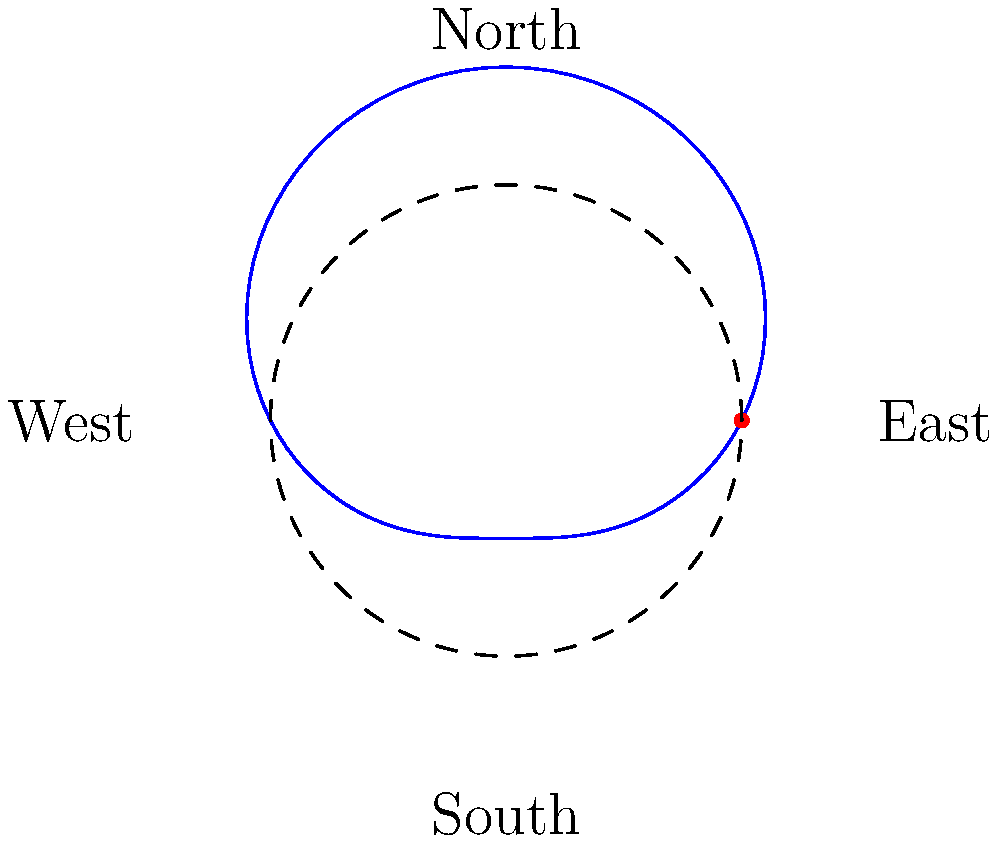In Padmabila Union, the daily movement of the sun across the sky can be represented using polar coordinates. If we consider the origin as the observer's position, east as the polar axis, and the angular coordinate measured counterclockwise from east, which equation best describes the sun's path?

A) $r = 4 + 2\sin(\theta)$
B) $r = 4 + 2\cos(\theta)$
C) $r = 2 + 4\sin(\theta)$
D) $r = 2 + 4\cos(\theta)$ To understand the sun's path in Padmabila Union using polar coordinates, let's break it down step-by-step:

1. The origin represents the observer's position in Padmabila Union.
2. The polar axis is aligned with the east direction.
3. The angular coordinate $\theta$ is measured counterclockwise from east.

Now, let's analyze the sun's movement:

4. At sunrise (east), $\theta = 0$, and the sun should be at its lowest point above the horizon.
5. At noon (north), $\theta = \frac{\pi}{2}$, and the sun should be at its highest point.
6. At sunset (west), $\theta = \pi$, and the sun should again be at its lowest point.

The equation $r = 4 + 2\sin(\theta)$ fits this pattern:

7. When $\theta = 0$ (east), $r = 4$ (lowest point)
8. When $\theta = \frac{\pi}{2}$ (north), $r = 6$ (highest point)
9. When $\theta = \pi$ (west), $r = 4$ (lowest point again)

This equation creates a curve that rises from east, reaches its peak in the north, and then descends towards the west, accurately representing the sun's daily path in Padmabila Union.
Answer: A) $r = 4 + 2\sin(\theta)$ 